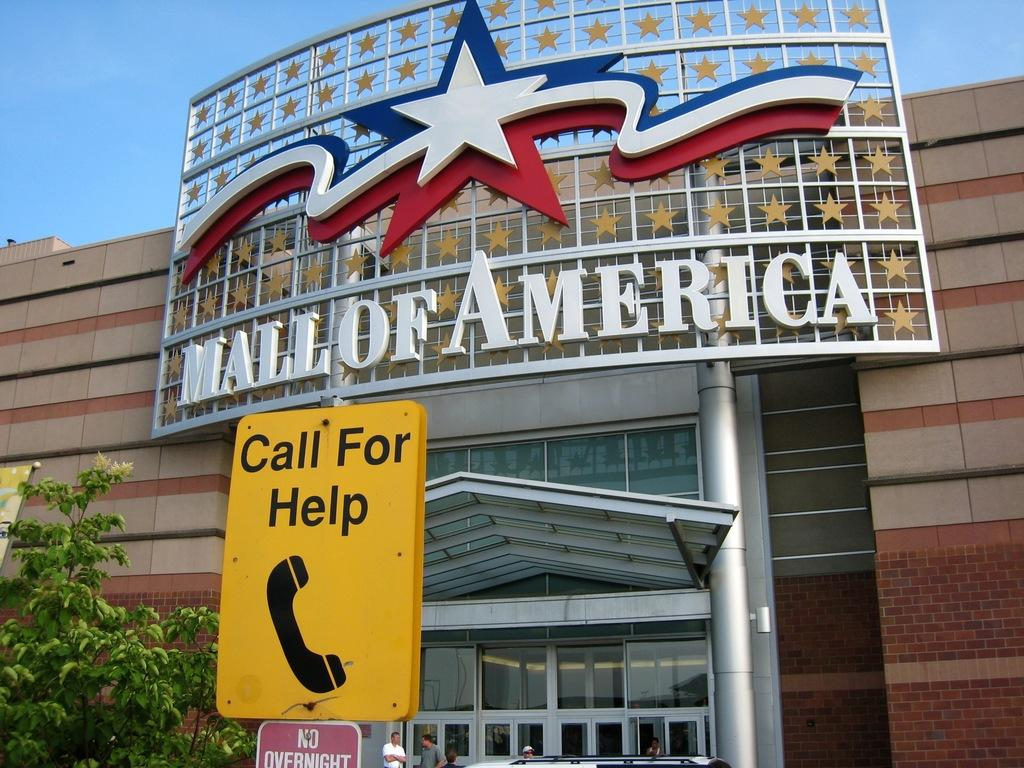What structure is visible in the image? There is a building in the image. What is located in front of the building? There are hoardings and a tree in front of the building. Are there any people present in the image? Yes, there are people in front of the building. What is the color of the sky in the image? The sky is blue in color. What type of page can be seen being turned by the stone in the image? There is no page or stone present in the image. How many cups are visible on the tree in the image? There are no cups visible on the tree in the image. 